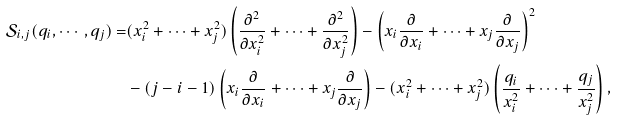Convert formula to latex. <formula><loc_0><loc_0><loc_500><loc_500>\mathcal { S } _ { i , j } ( q _ { i } , \cdots , q _ { j } ) = & ( x _ { i } ^ { 2 } + \cdots + x _ { j } ^ { 2 } ) \left ( \frac { \partial ^ { 2 } } { \partial x _ { i } ^ { 2 } } + \cdots + \frac { \partial ^ { 2 } } { \partial x _ { j } ^ { 2 } } \right ) - \left ( x _ { i } \frac { \partial } { \partial x _ { i } } + \cdots + x _ { j } \frac { \partial } { \partial x _ { j } } \right ) ^ { 2 } \\ & - ( j - i - 1 ) \left ( x _ { i } \frac { \partial } { \partial x _ { i } } + \cdots + x _ { j } \frac { \partial } { \partial x _ { j } } \right ) - ( x _ { i } ^ { 2 } + \cdots + x _ { j } ^ { 2 } ) \left ( \frac { q _ { i } } { x _ { i } ^ { 2 } } + \cdots + \frac { q _ { j } } { x _ { j } ^ { 2 } } \right ) ,</formula> 